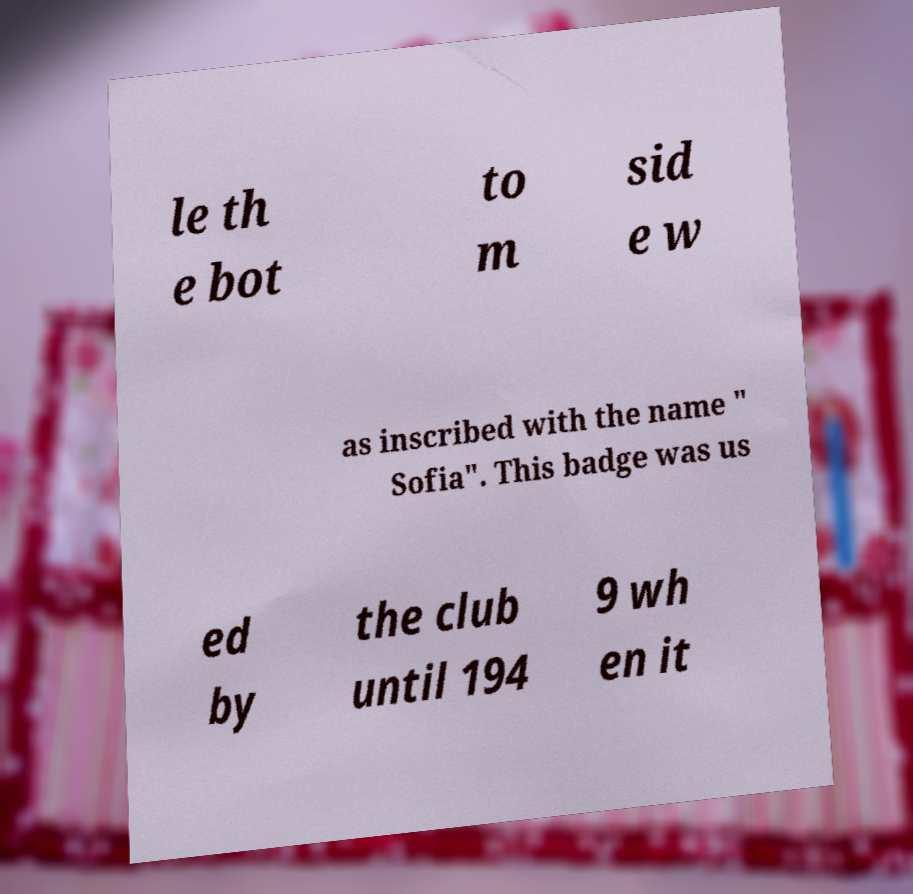Please read and relay the text visible in this image. What does it say? le th e bot to m sid e w as inscribed with the name " Sofia". This badge was us ed by the club until 194 9 wh en it 